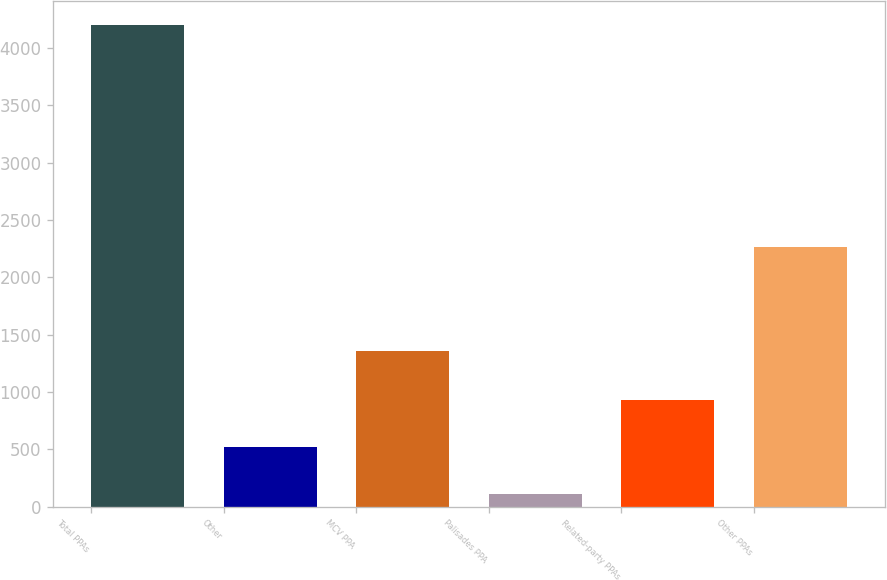Convert chart to OTSL. <chart><loc_0><loc_0><loc_500><loc_500><bar_chart><fcel>Total PPAs<fcel>Other<fcel>MCV PPA<fcel>Palisades PPA<fcel>Related-party PPAs<fcel>Other PPAs<nl><fcel>4201<fcel>521.8<fcel>1354<fcel>113<fcel>930.6<fcel>2260<nl></chart> 